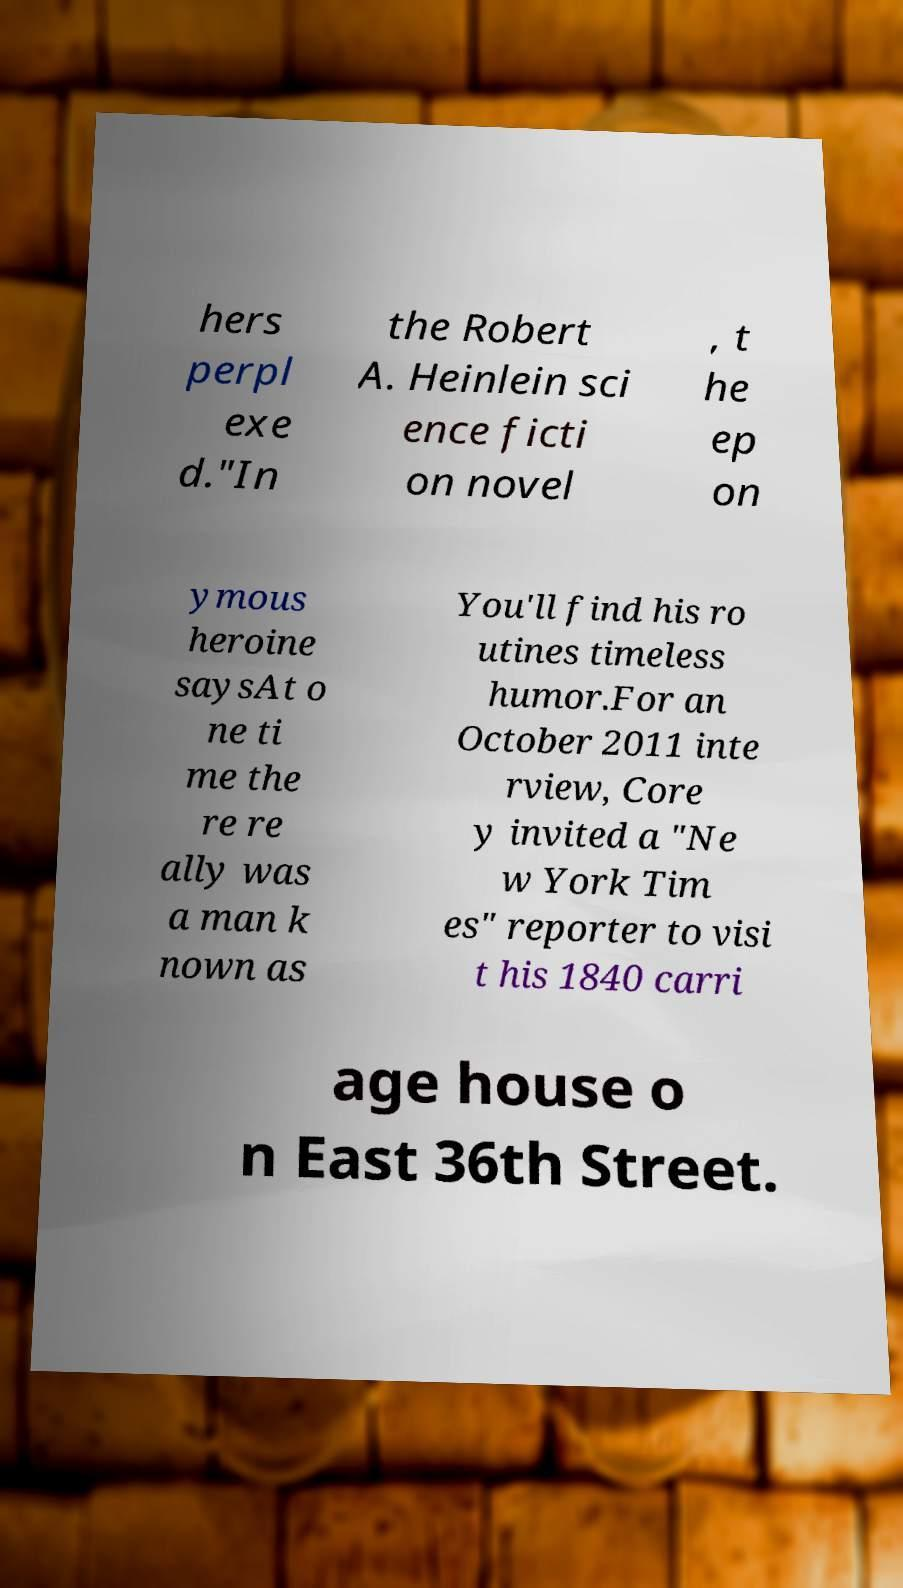I need the written content from this picture converted into text. Can you do that? hers perpl exe d."In the Robert A. Heinlein sci ence ficti on novel , t he ep on ymous heroine saysAt o ne ti me the re re ally was a man k nown as You'll find his ro utines timeless humor.For an October 2011 inte rview, Core y invited a "Ne w York Tim es" reporter to visi t his 1840 carri age house o n East 36th Street. 